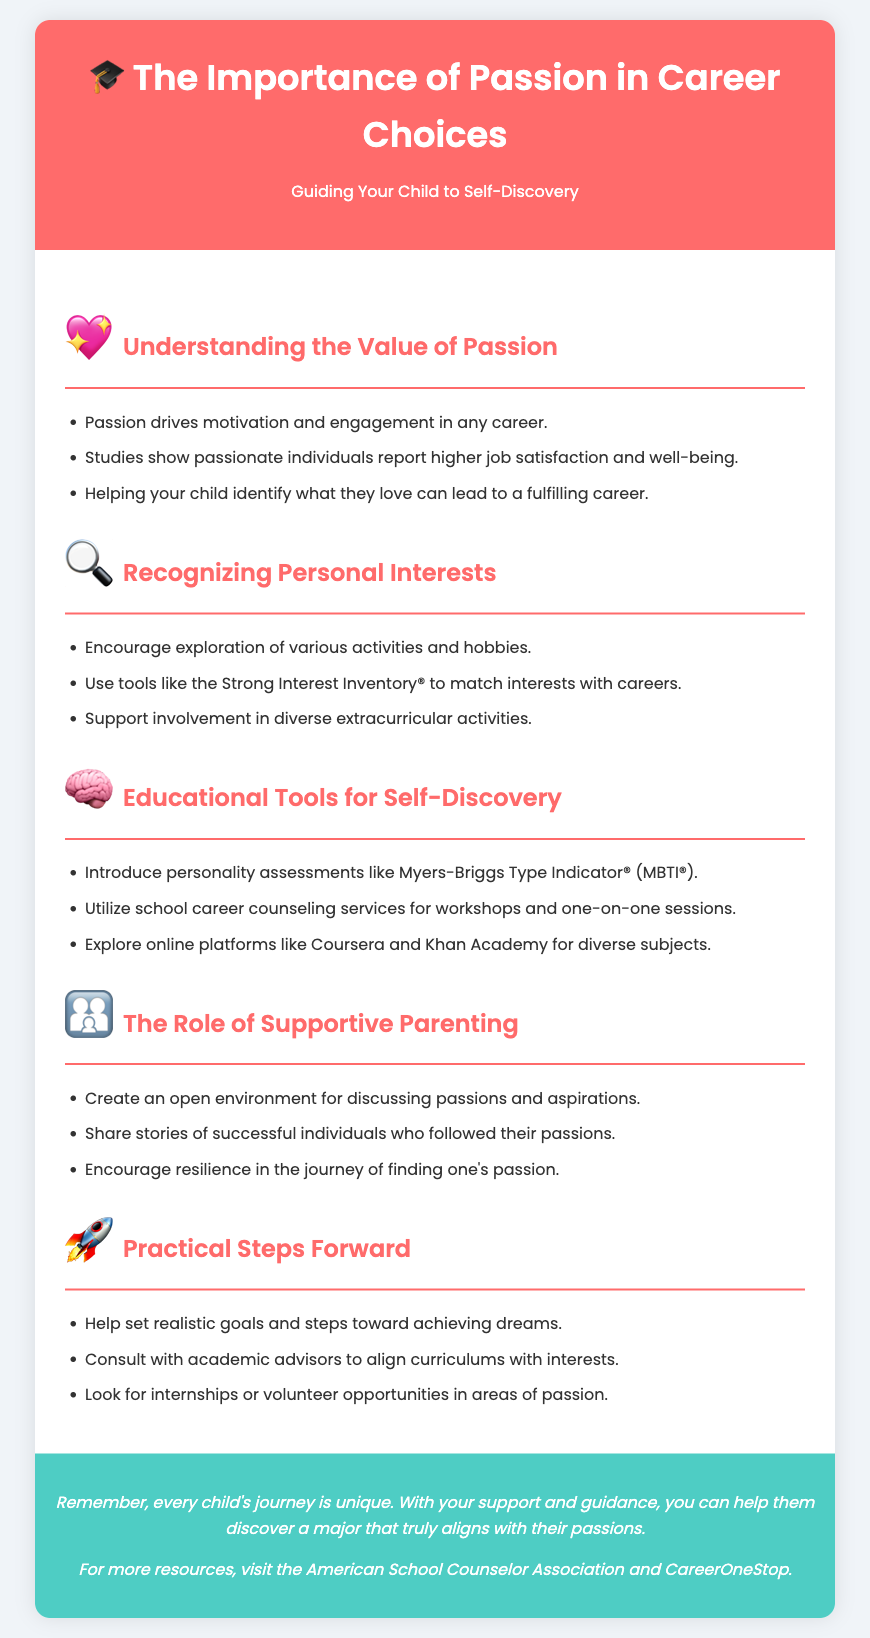What is the title of the flyer? The title of the flyer is located in the header section and states the topic of the document.
Answer: The Importance of Passion in Career Choices What color is the header background? The header background color is specified within the styles of the document.
Answer: #ff6b6b How many sections are there in the content? The number of sections can be counted from the main content area of the document.
Answer: Five What tool is suggested for matching interests with careers? This tool is explicitly mentioned in the "Recognizing Personal Interests" section of the document.
Answer: Strong Interest Inventory® What personality assessment is suggested for self-discovery? This assessment is highlighted in the "Educational Tools for Self-Discovery" section.
Answer: Myers-Briggs Type Indicator® What is one key role of supportive parenting mentioned? This role is referenced in the "The Role of Supportive Parenting" section and summarized.
Answer: Create an open environment What should be consulted to align curriculums with interests? This advice is given in the "Practical Steps Forward" section of the document.
Answer: Academic advisors What color is the footer background? The footer background color is specified within the styles of the document.
Answer: #4ecdc4 What does the flyer suggest about the uniqueness of a child's journey? This sentiment is expressed towards the end of the document in the footer.
Answer: Every child's journey is unique 